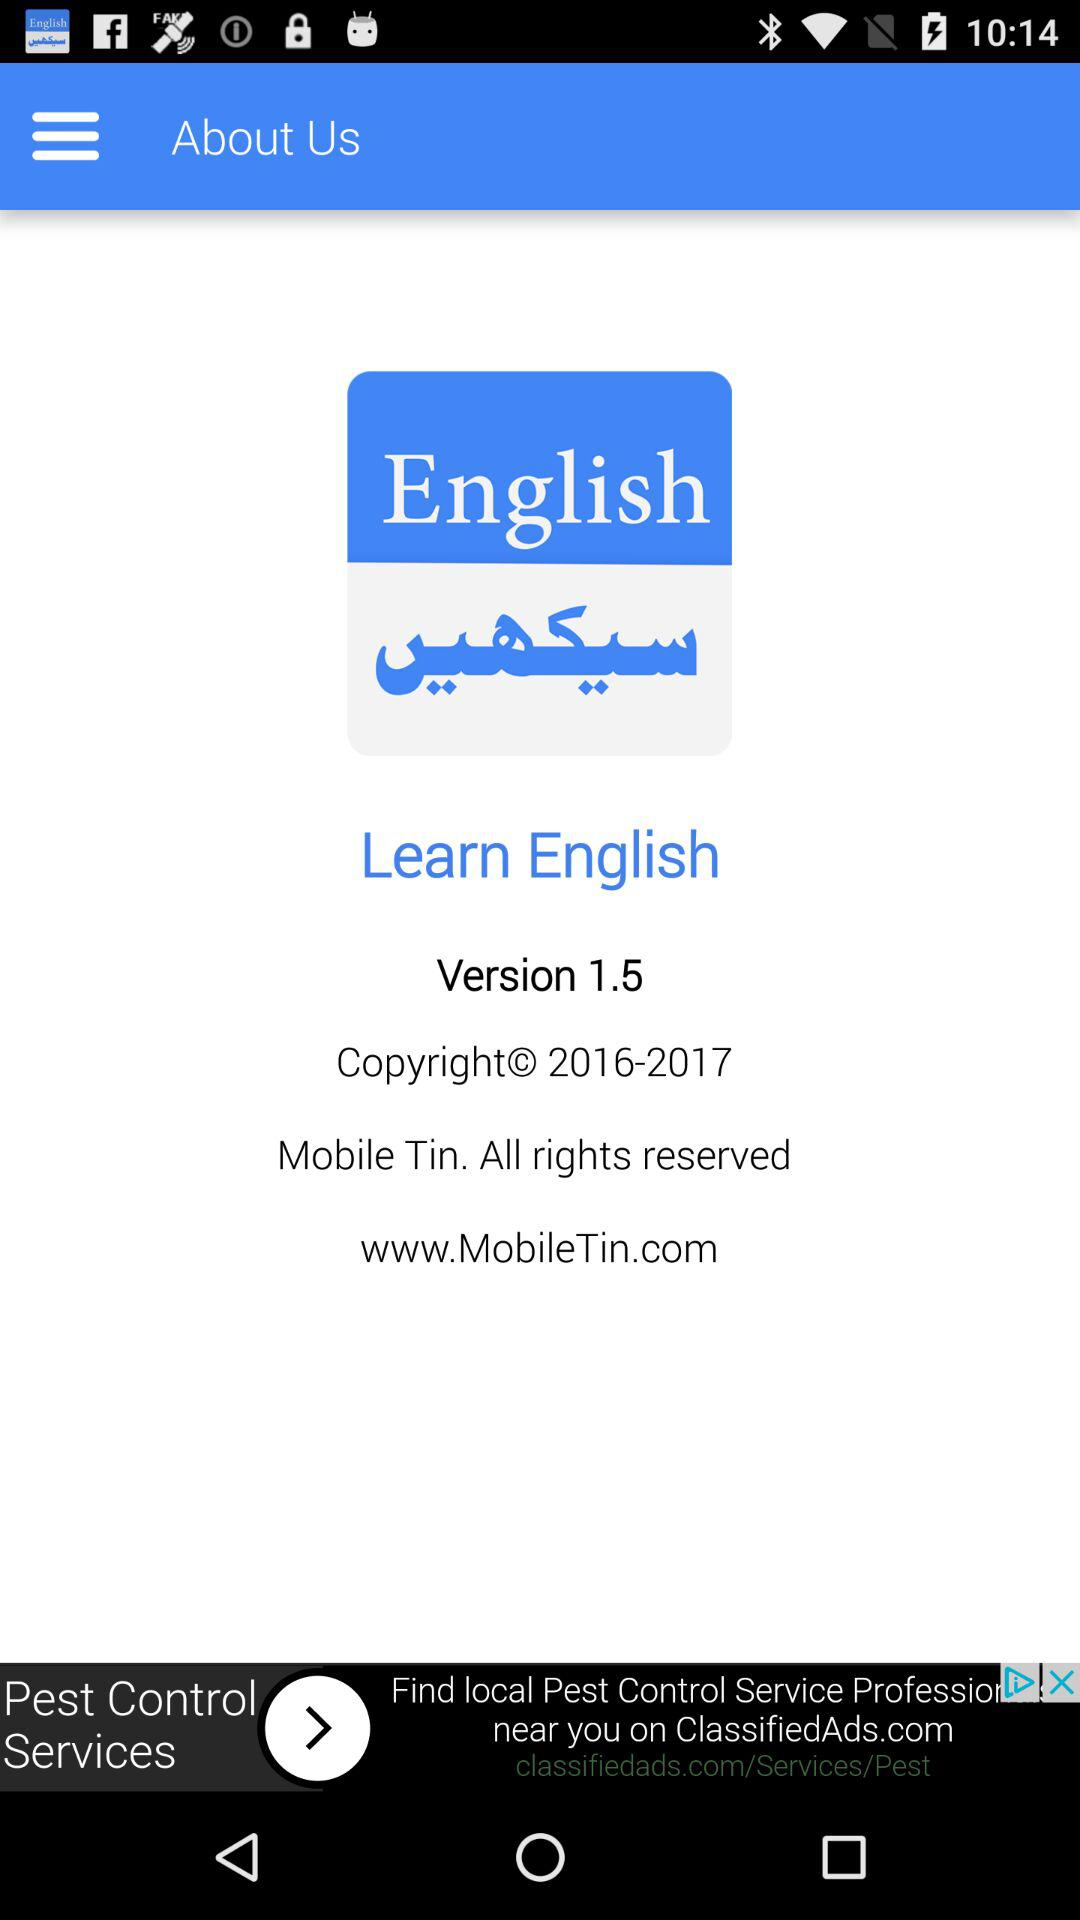What is the given copyright year? The copyright year is 2016-2017. 